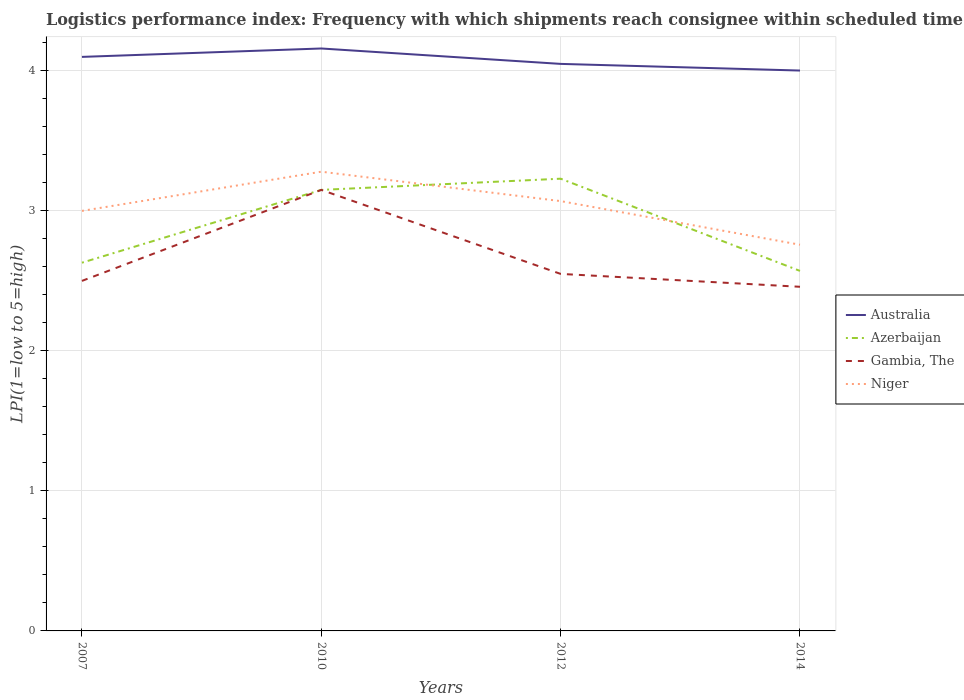Is the number of lines equal to the number of legend labels?
Ensure brevity in your answer.  Yes. Across all years, what is the maximum logistics performance index in Azerbaijan?
Provide a succinct answer. 2.57. What is the total logistics performance index in Australia in the graph?
Your answer should be very brief. 0.16. What is the difference between the highest and the second highest logistics performance index in Gambia, The?
Make the answer very short. 0.69. How many years are there in the graph?
Provide a succinct answer. 4. Does the graph contain grids?
Ensure brevity in your answer.  Yes. Where does the legend appear in the graph?
Offer a terse response. Center right. What is the title of the graph?
Your response must be concise. Logistics performance index: Frequency with which shipments reach consignee within scheduled time. Does "Solomon Islands" appear as one of the legend labels in the graph?
Ensure brevity in your answer.  No. What is the label or title of the Y-axis?
Keep it short and to the point. LPI(1=low to 5=high). What is the LPI(1=low to 5=high) of Australia in 2007?
Offer a very short reply. 4.1. What is the LPI(1=low to 5=high) in Azerbaijan in 2007?
Provide a short and direct response. 2.63. What is the LPI(1=low to 5=high) in Gambia, The in 2007?
Provide a succinct answer. 2.5. What is the LPI(1=low to 5=high) of Niger in 2007?
Give a very brief answer. 3. What is the LPI(1=low to 5=high) in Australia in 2010?
Provide a short and direct response. 4.16. What is the LPI(1=low to 5=high) in Azerbaijan in 2010?
Your answer should be compact. 3.15. What is the LPI(1=low to 5=high) in Gambia, The in 2010?
Offer a very short reply. 3.15. What is the LPI(1=low to 5=high) in Niger in 2010?
Keep it short and to the point. 3.28. What is the LPI(1=low to 5=high) in Australia in 2012?
Give a very brief answer. 4.05. What is the LPI(1=low to 5=high) of Azerbaijan in 2012?
Make the answer very short. 3.23. What is the LPI(1=low to 5=high) of Gambia, The in 2012?
Make the answer very short. 2.55. What is the LPI(1=low to 5=high) in Niger in 2012?
Ensure brevity in your answer.  3.07. What is the LPI(1=low to 5=high) of Australia in 2014?
Make the answer very short. 4. What is the LPI(1=low to 5=high) of Azerbaijan in 2014?
Make the answer very short. 2.57. What is the LPI(1=low to 5=high) in Gambia, The in 2014?
Provide a succinct answer. 2.46. What is the LPI(1=low to 5=high) of Niger in 2014?
Offer a terse response. 2.76. Across all years, what is the maximum LPI(1=low to 5=high) in Australia?
Your answer should be compact. 4.16. Across all years, what is the maximum LPI(1=low to 5=high) in Azerbaijan?
Give a very brief answer. 3.23. Across all years, what is the maximum LPI(1=low to 5=high) of Gambia, The?
Your answer should be very brief. 3.15. Across all years, what is the maximum LPI(1=low to 5=high) in Niger?
Give a very brief answer. 3.28. Across all years, what is the minimum LPI(1=low to 5=high) in Australia?
Give a very brief answer. 4. Across all years, what is the minimum LPI(1=low to 5=high) in Azerbaijan?
Offer a very short reply. 2.57. Across all years, what is the minimum LPI(1=low to 5=high) of Gambia, The?
Offer a terse response. 2.46. Across all years, what is the minimum LPI(1=low to 5=high) in Niger?
Ensure brevity in your answer.  2.76. What is the total LPI(1=low to 5=high) of Australia in the graph?
Provide a short and direct response. 16.31. What is the total LPI(1=low to 5=high) of Azerbaijan in the graph?
Your answer should be very brief. 11.58. What is the total LPI(1=low to 5=high) of Gambia, The in the graph?
Offer a very short reply. 10.66. What is the total LPI(1=low to 5=high) of Niger in the graph?
Provide a short and direct response. 12.11. What is the difference between the LPI(1=low to 5=high) in Australia in 2007 and that in 2010?
Your answer should be very brief. -0.06. What is the difference between the LPI(1=low to 5=high) in Azerbaijan in 2007 and that in 2010?
Give a very brief answer. -0.52. What is the difference between the LPI(1=low to 5=high) in Gambia, The in 2007 and that in 2010?
Provide a short and direct response. -0.65. What is the difference between the LPI(1=low to 5=high) of Niger in 2007 and that in 2010?
Give a very brief answer. -0.28. What is the difference between the LPI(1=low to 5=high) of Niger in 2007 and that in 2012?
Provide a succinct answer. -0.07. What is the difference between the LPI(1=low to 5=high) in Australia in 2007 and that in 2014?
Your answer should be very brief. 0.1. What is the difference between the LPI(1=low to 5=high) of Azerbaijan in 2007 and that in 2014?
Offer a very short reply. 0.06. What is the difference between the LPI(1=low to 5=high) of Gambia, The in 2007 and that in 2014?
Provide a succinct answer. 0.04. What is the difference between the LPI(1=low to 5=high) in Niger in 2007 and that in 2014?
Provide a succinct answer. 0.24. What is the difference between the LPI(1=low to 5=high) in Australia in 2010 and that in 2012?
Offer a very short reply. 0.11. What is the difference between the LPI(1=low to 5=high) in Azerbaijan in 2010 and that in 2012?
Your answer should be very brief. -0.08. What is the difference between the LPI(1=low to 5=high) in Gambia, The in 2010 and that in 2012?
Your answer should be very brief. 0.6. What is the difference between the LPI(1=low to 5=high) of Niger in 2010 and that in 2012?
Ensure brevity in your answer.  0.21. What is the difference between the LPI(1=low to 5=high) in Australia in 2010 and that in 2014?
Your answer should be compact. 0.16. What is the difference between the LPI(1=low to 5=high) in Azerbaijan in 2010 and that in 2014?
Give a very brief answer. 0.58. What is the difference between the LPI(1=low to 5=high) of Gambia, The in 2010 and that in 2014?
Give a very brief answer. 0.69. What is the difference between the LPI(1=low to 5=high) in Niger in 2010 and that in 2014?
Provide a short and direct response. 0.52. What is the difference between the LPI(1=low to 5=high) in Australia in 2012 and that in 2014?
Provide a short and direct response. 0.05. What is the difference between the LPI(1=low to 5=high) in Azerbaijan in 2012 and that in 2014?
Give a very brief answer. 0.66. What is the difference between the LPI(1=low to 5=high) of Gambia, The in 2012 and that in 2014?
Provide a succinct answer. 0.09. What is the difference between the LPI(1=low to 5=high) of Niger in 2012 and that in 2014?
Offer a very short reply. 0.31. What is the difference between the LPI(1=low to 5=high) in Australia in 2007 and the LPI(1=low to 5=high) in Niger in 2010?
Provide a short and direct response. 0.82. What is the difference between the LPI(1=low to 5=high) in Azerbaijan in 2007 and the LPI(1=low to 5=high) in Gambia, The in 2010?
Your answer should be compact. -0.52. What is the difference between the LPI(1=low to 5=high) of Azerbaijan in 2007 and the LPI(1=low to 5=high) of Niger in 2010?
Your answer should be very brief. -0.65. What is the difference between the LPI(1=low to 5=high) of Gambia, The in 2007 and the LPI(1=low to 5=high) of Niger in 2010?
Your answer should be very brief. -0.78. What is the difference between the LPI(1=low to 5=high) in Australia in 2007 and the LPI(1=low to 5=high) in Azerbaijan in 2012?
Offer a terse response. 0.87. What is the difference between the LPI(1=low to 5=high) of Australia in 2007 and the LPI(1=low to 5=high) of Gambia, The in 2012?
Offer a terse response. 1.55. What is the difference between the LPI(1=low to 5=high) in Australia in 2007 and the LPI(1=low to 5=high) in Niger in 2012?
Make the answer very short. 1.03. What is the difference between the LPI(1=low to 5=high) of Azerbaijan in 2007 and the LPI(1=low to 5=high) of Gambia, The in 2012?
Your response must be concise. 0.08. What is the difference between the LPI(1=low to 5=high) of Azerbaijan in 2007 and the LPI(1=low to 5=high) of Niger in 2012?
Give a very brief answer. -0.44. What is the difference between the LPI(1=low to 5=high) of Gambia, The in 2007 and the LPI(1=low to 5=high) of Niger in 2012?
Ensure brevity in your answer.  -0.57. What is the difference between the LPI(1=low to 5=high) in Australia in 2007 and the LPI(1=low to 5=high) in Azerbaijan in 2014?
Provide a short and direct response. 1.53. What is the difference between the LPI(1=low to 5=high) of Australia in 2007 and the LPI(1=low to 5=high) of Gambia, The in 2014?
Provide a short and direct response. 1.64. What is the difference between the LPI(1=low to 5=high) of Australia in 2007 and the LPI(1=low to 5=high) of Niger in 2014?
Offer a very short reply. 1.34. What is the difference between the LPI(1=low to 5=high) of Azerbaijan in 2007 and the LPI(1=low to 5=high) of Gambia, The in 2014?
Your answer should be compact. 0.17. What is the difference between the LPI(1=low to 5=high) in Azerbaijan in 2007 and the LPI(1=low to 5=high) in Niger in 2014?
Your response must be concise. -0.13. What is the difference between the LPI(1=low to 5=high) in Gambia, The in 2007 and the LPI(1=low to 5=high) in Niger in 2014?
Your response must be concise. -0.26. What is the difference between the LPI(1=low to 5=high) of Australia in 2010 and the LPI(1=low to 5=high) of Gambia, The in 2012?
Make the answer very short. 1.61. What is the difference between the LPI(1=low to 5=high) of Australia in 2010 and the LPI(1=low to 5=high) of Niger in 2012?
Ensure brevity in your answer.  1.09. What is the difference between the LPI(1=low to 5=high) in Azerbaijan in 2010 and the LPI(1=low to 5=high) in Gambia, The in 2012?
Offer a very short reply. 0.6. What is the difference between the LPI(1=low to 5=high) of Gambia, The in 2010 and the LPI(1=low to 5=high) of Niger in 2012?
Offer a terse response. 0.08. What is the difference between the LPI(1=low to 5=high) of Australia in 2010 and the LPI(1=low to 5=high) of Azerbaijan in 2014?
Your response must be concise. 1.59. What is the difference between the LPI(1=low to 5=high) of Australia in 2010 and the LPI(1=low to 5=high) of Gambia, The in 2014?
Offer a terse response. 1.7. What is the difference between the LPI(1=low to 5=high) of Australia in 2010 and the LPI(1=low to 5=high) of Niger in 2014?
Provide a succinct answer. 1.4. What is the difference between the LPI(1=low to 5=high) of Azerbaijan in 2010 and the LPI(1=low to 5=high) of Gambia, The in 2014?
Make the answer very short. 0.69. What is the difference between the LPI(1=low to 5=high) in Azerbaijan in 2010 and the LPI(1=low to 5=high) in Niger in 2014?
Make the answer very short. 0.39. What is the difference between the LPI(1=low to 5=high) in Gambia, The in 2010 and the LPI(1=low to 5=high) in Niger in 2014?
Provide a succinct answer. 0.39. What is the difference between the LPI(1=low to 5=high) of Australia in 2012 and the LPI(1=low to 5=high) of Azerbaijan in 2014?
Provide a short and direct response. 1.48. What is the difference between the LPI(1=low to 5=high) in Australia in 2012 and the LPI(1=low to 5=high) in Gambia, The in 2014?
Your answer should be compact. 1.59. What is the difference between the LPI(1=low to 5=high) in Australia in 2012 and the LPI(1=low to 5=high) in Niger in 2014?
Keep it short and to the point. 1.29. What is the difference between the LPI(1=low to 5=high) in Azerbaijan in 2012 and the LPI(1=low to 5=high) in Gambia, The in 2014?
Your answer should be very brief. 0.77. What is the difference between the LPI(1=low to 5=high) in Azerbaijan in 2012 and the LPI(1=low to 5=high) in Niger in 2014?
Offer a very short reply. 0.47. What is the difference between the LPI(1=low to 5=high) in Gambia, The in 2012 and the LPI(1=low to 5=high) in Niger in 2014?
Offer a very short reply. -0.21. What is the average LPI(1=low to 5=high) of Australia per year?
Offer a very short reply. 4.08. What is the average LPI(1=low to 5=high) of Azerbaijan per year?
Ensure brevity in your answer.  2.9. What is the average LPI(1=low to 5=high) of Gambia, The per year?
Give a very brief answer. 2.66. What is the average LPI(1=low to 5=high) in Niger per year?
Keep it short and to the point. 3.03. In the year 2007, what is the difference between the LPI(1=low to 5=high) in Australia and LPI(1=low to 5=high) in Azerbaijan?
Ensure brevity in your answer.  1.47. In the year 2007, what is the difference between the LPI(1=low to 5=high) in Australia and LPI(1=low to 5=high) in Gambia, The?
Your response must be concise. 1.6. In the year 2007, what is the difference between the LPI(1=low to 5=high) of Australia and LPI(1=low to 5=high) of Niger?
Offer a very short reply. 1.1. In the year 2007, what is the difference between the LPI(1=low to 5=high) in Azerbaijan and LPI(1=low to 5=high) in Gambia, The?
Keep it short and to the point. 0.13. In the year 2007, what is the difference between the LPI(1=low to 5=high) of Azerbaijan and LPI(1=low to 5=high) of Niger?
Your answer should be very brief. -0.37. In the year 2007, what is the difference between the LPI(1=low to 5=high) in Gambia, The and LPI(1=low to 5=high) in Niger?
Provide a succinct answer. -0.5. In the year 2010, what is the difference between the LPI(1=low to 5=high) of Australia and LPI(1=low to 5=high) of Azerbaijan?
Keep it short and to the point. 1.01. In the year 2010, what is the difference between the LPI(1=low to 5=high) in Australia and LPI(1=low to 5=high) in Niger?
Your answer should be very brief. 0.88. In the year 2010, what is the difference between the LPI(1=low to 5=high) in Azerbaijan and LPI(1=low to 5=high) in Niger?
Offer a terse response. -0.13. In the year 2010, what is the difference between the LPI(1=low to 5=high) in Gambia, The and LPI(1=low to 5=high) in Niger?
Give a very brief answer. -0.13. In the year 2012, what is the difference between the LPI(1=low to 5=high) in Australia and LPI(1=low to 5=high) in Azerbaijan?
Give a very brief answer. 0.82. In the year 2012, what is the difference between the LPI(1=low to 5=high) of Australia and LPI(1=low to 5=high) of Niger?
Keep it short and to the point. 0.98. In the year 2012, what is the difference between the LPI(1=low to 5=high) of Azerbaijan and LPI(1=low to 5=high) of Gambia, The?
Provide a short and direct response. 0.68. In the year 2012, what is the difference between the LPI(1=low to 5=high) of Azerbaijan and LPI(1=low to 5=high) of Niger?
Give a very brief answer. 0.16. In the year 2012, what is the difference between the LPI(1=low to 5=high) of Gambia, The and LPI(1=low to 5=high) of Niger?
Your answer should be very brief. -0.52. In the year 2014, what is the difference between the LPI(1=low to 5=high) of Australia and LPI(1=low to 5=high) of Azerbaijan?
Make the answer very short. 1.43. In the year 2014, what is the difference between the LPI(1=low to 5=high) in Australia and LPI(1=low to 5=high) in Gambia, The?
Offer a terse response. 1.54. In the year 2014, what is the difference between the LPI(1=low to 5=high) in Australia and LPI(1=low to 5=high) in Niger?
Offer a terse response. 1.24. In the year 2014, what is the difference between the LPI(1=low to 5=high) in Azerbaijan and LPI(1=low to 5=high) in Gambia, The?
Offer a terse response. 0.11. In the year 2014, what is the difference between the LPI(1=low to 5=high) in Azerbaijan and LPI(1=low to 5=high) in Niger?
Your response must be concise. -0.19. In the year 2014, what is the difference between the LPI(1=low to 5=high) of Gambia, The and LPI(1=low to 5=high) of Niger?
Keep it short and to the point. -0.3. What is the ratio of the LPI(1=low to 5=high) in Australia in 2007 to that in 2010?
Offer a terse response. 0.99. What is the ratio of the LPI(1=low to 5=high) of Azerbaijan in 2007 to that in 2010?
Offer a terse response. 0.83. What is the ratio of the LPI(1=low to 5=high) of Gambia, The in 2007 to that in 2010?
Offer a very short reply. 0.79. What is the ratio of the LPI(1=low to 5=high) of Niger in 2007 to that in 2010?
Provide a short and direct response. 0.91. What is the ratio of the LPI(1=low to 5=high) in Australia in 2007 to that in 2012?
Provide a short and direct response. 1.01. What is the ratio of the LPI(1=low to 5=high) of Azerbaijan in 2007 to that in 2012?
Your answer should be compact. 0.81. What is the ratio of the LPI(1=low to 5=high) in Gambia, The in 2007 to that in 2012?
Make the answer very short. 0.98. What is the ratio of the LPI(1=low to 5=high) in Niger in 2007 to that in 2012?
Make the answer very short. 0.98. What is the ratio of the LPI(1=low to 5=high) of Australia in 2007 to that in 2014?
Offer a terse response. 1.02. What is the ratio of the LPI(1=low to 5=high) in Azerbaijan in 2007 to that in 2014?
Ensure brevity in your answer.  1.02. What is the ratio of the LPI(1=low to 5=high) in Gambia, The in 2007 to that in 2014?
Provide a succinct answer. 1.02. What is the ratio of the LPI(1=low to 5=high) in Niger in 2007 to that in 2014?
Your answer should be compact. 1.09. What is the ratio of the LPI(1=low to 5=high) of Australia in 2010 to that in 2012?
Ensure brevity in your answer.  1.03. What is the ratio of the LPI(1=low to 5=high) of Azerbaijan in 2010 to that in 2012?
Keep it short and to the point. 0.98. What is the ratio of the LPI(1=low to 5=high) in Gambia, The in 2010 to that in 2012?
Your answer should be compact. 1.24. What is the ratio of the LPI(1=low to 5=high) of Niger in 2010 to that in 2012?
Offer a terse response. 1.07. What is the ratio of the LPI(1=low to 5=high) of Australia in 2010 to that in 2014?
Your answer should be compact. 1.04. What is the ratio of the LPI(1=low to 5=high) in Azerbaijan in 2010 to that in 2014?
Provide a short and direct response. 1.23. What is the ratio of the LPI(1=low to 5=high) in Gambia, The in 2010 to that in 2014?
Ensure brevity in your answer.  1.28. What is the ratio of the LPI(1=low to 5=high) in Niger in 2010 to that in 2014?
Provide a short and direct response. 1.19. What is the ratio of the LPI(1=low to 5=high) in Australia in 2012 to that in 2014?
Make the answer very short. 1.01. What is the ratio of the LPI(1=low to 5=high) in Azerbaijan in 2012 to that in 2014?
Provide a succinct answer. 1.26. What is the ratio of the LPI(1=low to 5=high) in Gambia, The in 2012 to that in 2014?
Provide a succinct answer. 1.04. What is the ratio of the LPI(1=low to 5=high) of Niger in 2012 to that in 2014?
Keep it short and to the point. 1.11. What is the difference between the highest and the second highest LPI(1=low to 5=high) in Niger?
Give a very brief answer. 0.21. What is the difference between the highest and the lowest LPI(1=low to 5=high) of Australia?
Ensure brevity in your answer.  0.16. What is the difference between the highest and the lowest LPI(1=low to 5=high) of Azerbaijan?
Keep it short and to the point. 0.66. What is the difference between the highest and the lowest LPI(1=low to 5=high) of Gambia, The?
Provide a succinct answer. 0.69. What is the difference between the highest and the lowest LPI(1=low to 5=high) of Niger?
Offer a terse response. 0.52. 